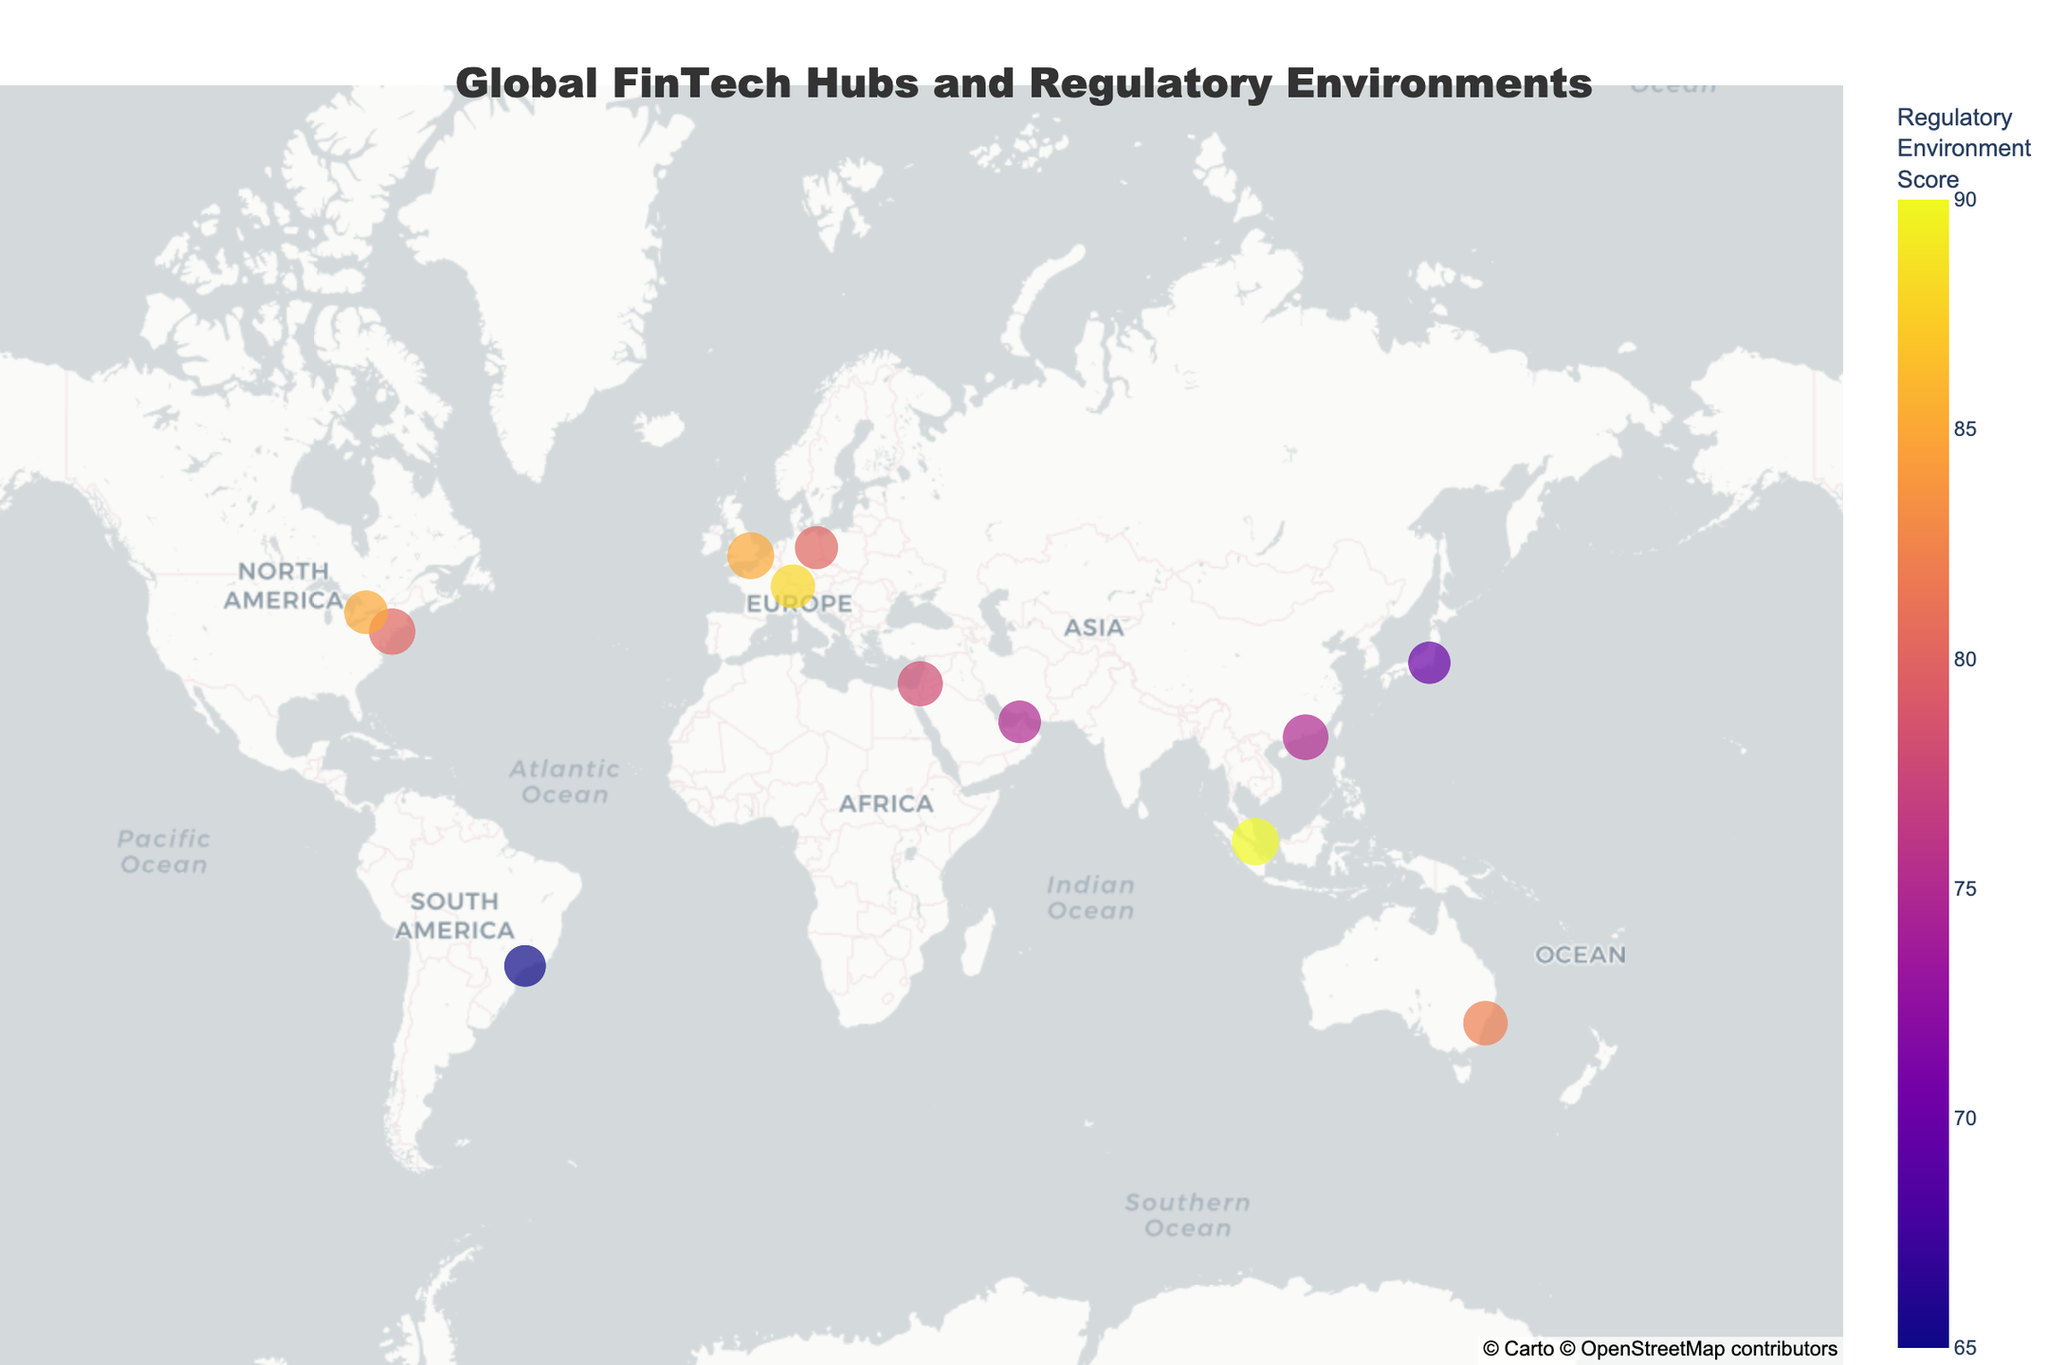What's the city with the highest FinTech Hub Score? The city with the highest FinTech Hub Score would have the largest circle on the map. By inspecting the sizes, we can see that Singapore has the largest circle.
Answer: Singapore Which city has the lowest Regulatory Environment Score? The color of the circles represents the Regulatory Environment Score. The lighter the color, the lower the score. São Paulo has the lightest color, indicating the lowest Regulatory Environment Score.
Answer: São Paulo How many cities are depicted on the map? Count the number of distinct circles plotted on the map. There are 12 cities represented by 12 circles.
Answer: 12 What's the notable regulatory feature of Hong Kong? By hovering over the Hong Kong circle or checking the legend, you can see that Hong Kong is noted for its Virtual banking licenses.
Answer: Virtual banking licenses Which city is geographically the closest to the equator? Identify the city with a latitude closest to 0. Singapore is the nearest to the equator with a latitude of 1.3521.
Answer: Singapore Where is the FinTech Hive accelerator program located? By looking at the points and their corresponding annotations, Dubai has the FinTech Hive accelerator program.
Answer: Dubai What is the difference in FinTech Hub Scores between the highest and lowest scoring cities? The highest FinTech Hub Score is 95 (Singapore) and the lowest is 74 (São Paulo). The difference is 95 - 74 = 21.
Answer: 21 Which two cities have the same Regulatory Environment Score, and what is that score? By matching the circles with similar colors and scores, we find that London and Toronto both have a Regulatory Environment Score of 85.
Answer: London and Toronto, 85 Compare the Regulatory Environment Scores of Zurich and Tokyo. Which city has a higher score? Zurich has a Regulatory Environment Score of 88, while Tokyo has a score of 70. Thus, Zurich has a higher score.
Answer: Zurich How does the FinTech Hub Score of New York compare to that of Tel Aviv? New York has a FinTech Hub Score of 91, while Tel Aviv has a score of 86. New York has a higher FinTech Hub Score.
Answer: New York 